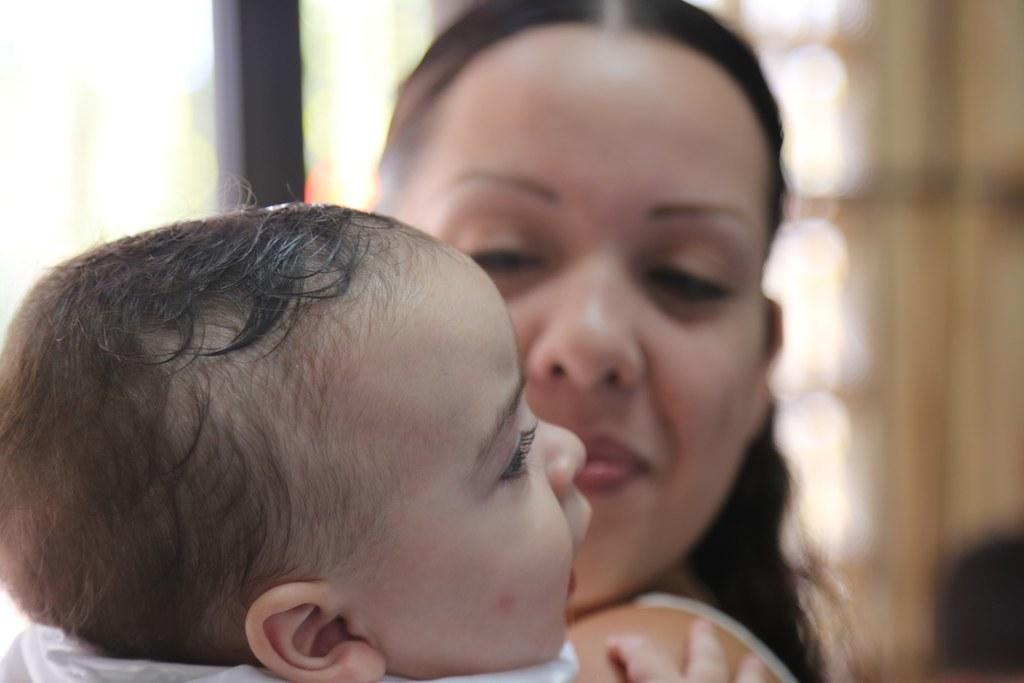What is the main subject of the image? There is a baby in the image. Are there any other people in the image besides the baby? Yes, there is a lady in the image. What type of skirt is the ship wearing in the image? There is no ship present in the image, and therefore no skirt or ship can be observed. 